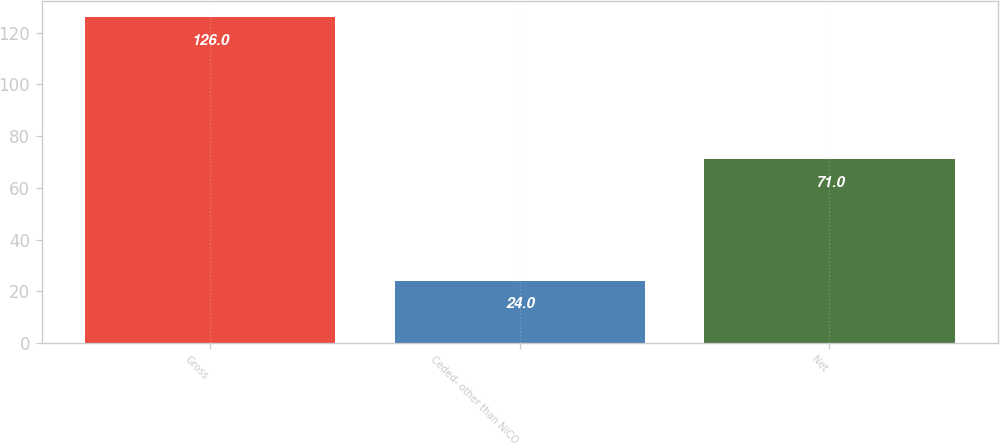Convert chart. <chart><loc_0><loc_0><loc_500><loc_500><bar_chart><fcel>Gross<fcel>Ceded- other than NICO<fcel>Net<nl><fcel>126<fcel>24<fcel>71<nl></chart> 